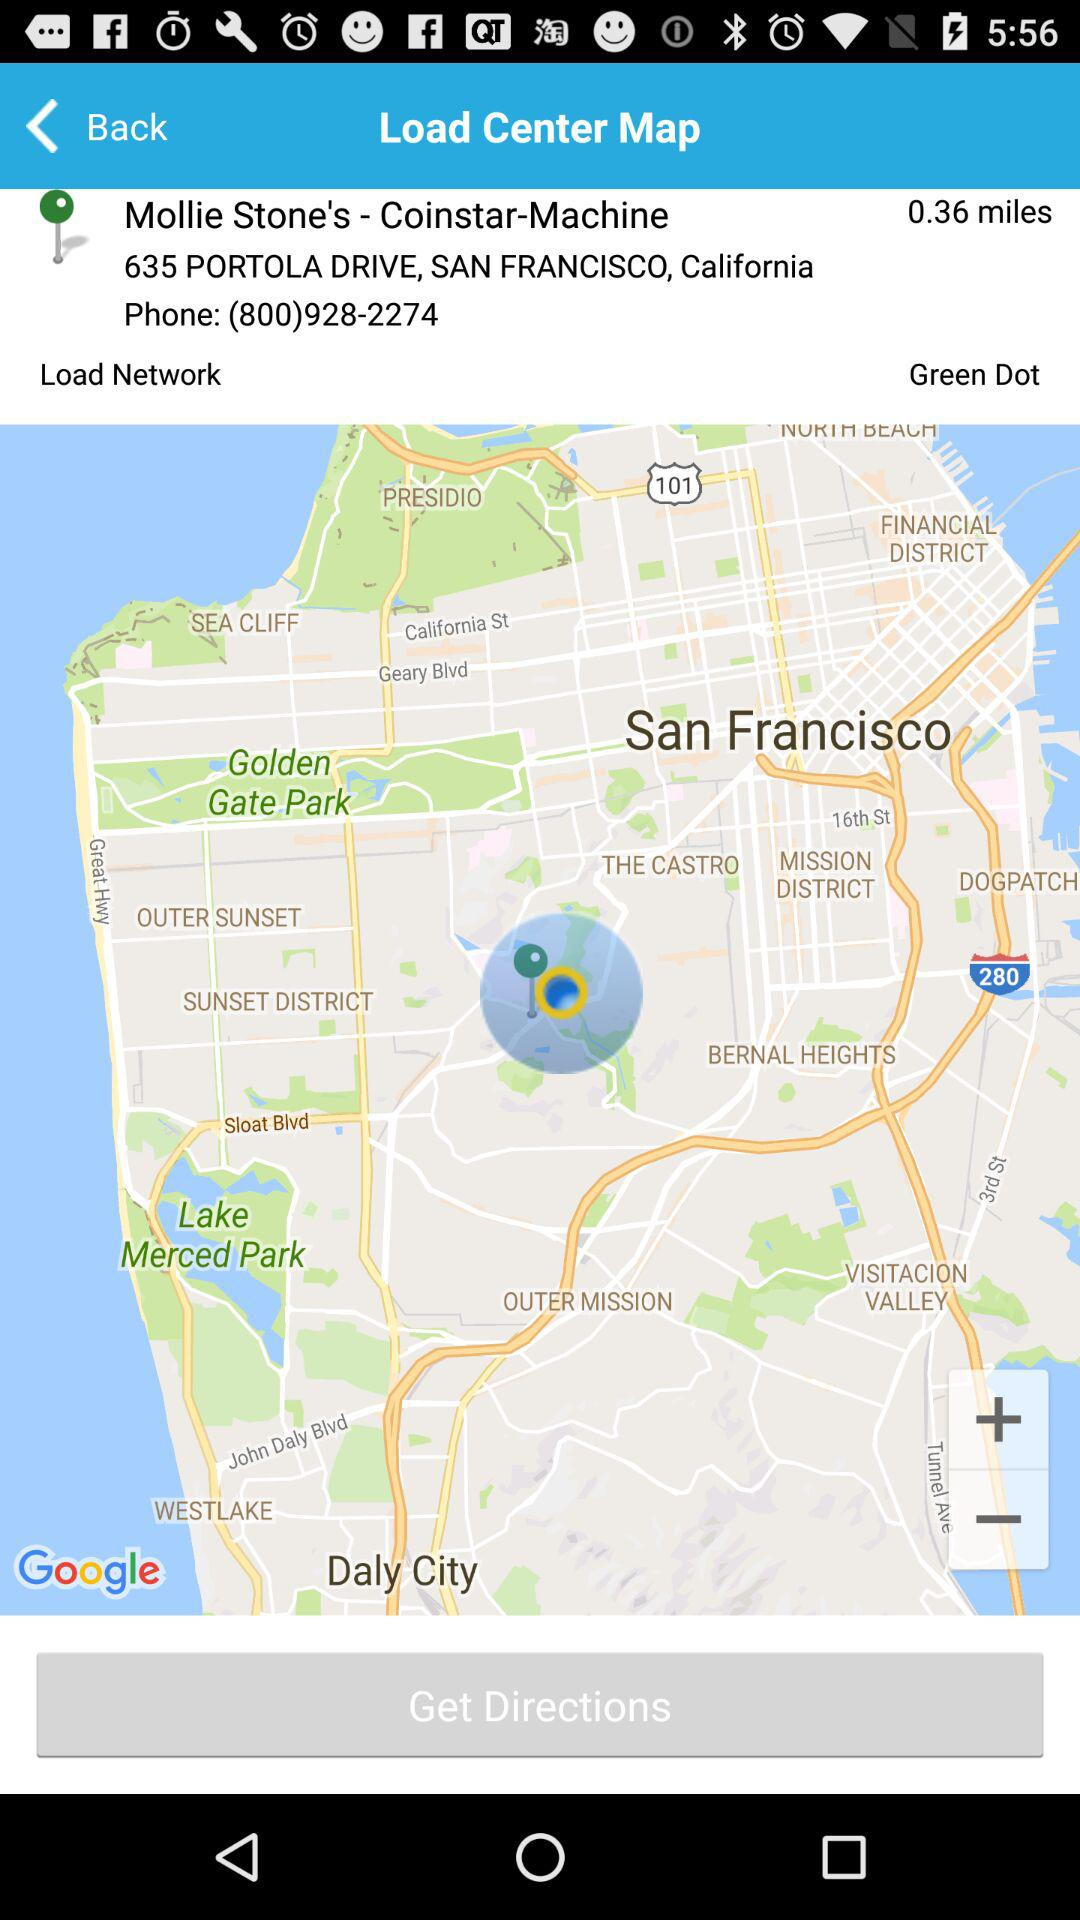What is the phone number? The phone number is (800)928-2274. 